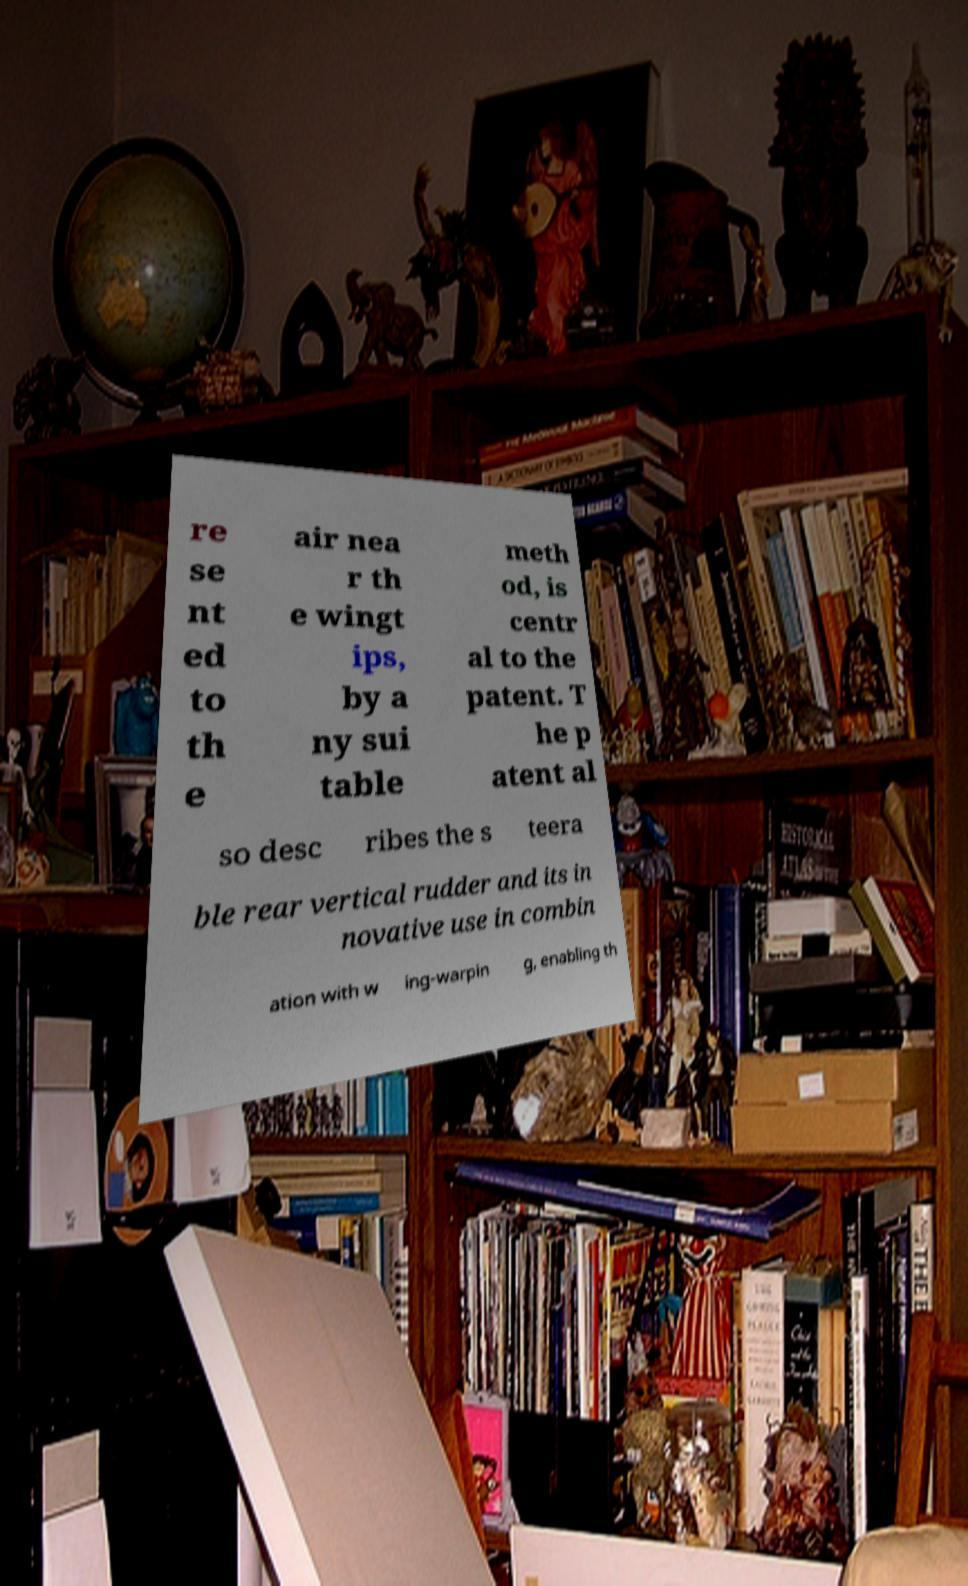There's text embedded in this image that I need extracted. Can you transcribe it verbatim? re se nt ed to th e air nea r th e wingt ips, by a ny sui table meth od, is centr al to the patent. T he p atent al so desc ribes the s teera ble rear vertical rudder and its in novative use in combin ation with w ing-warpin g, enabling th 